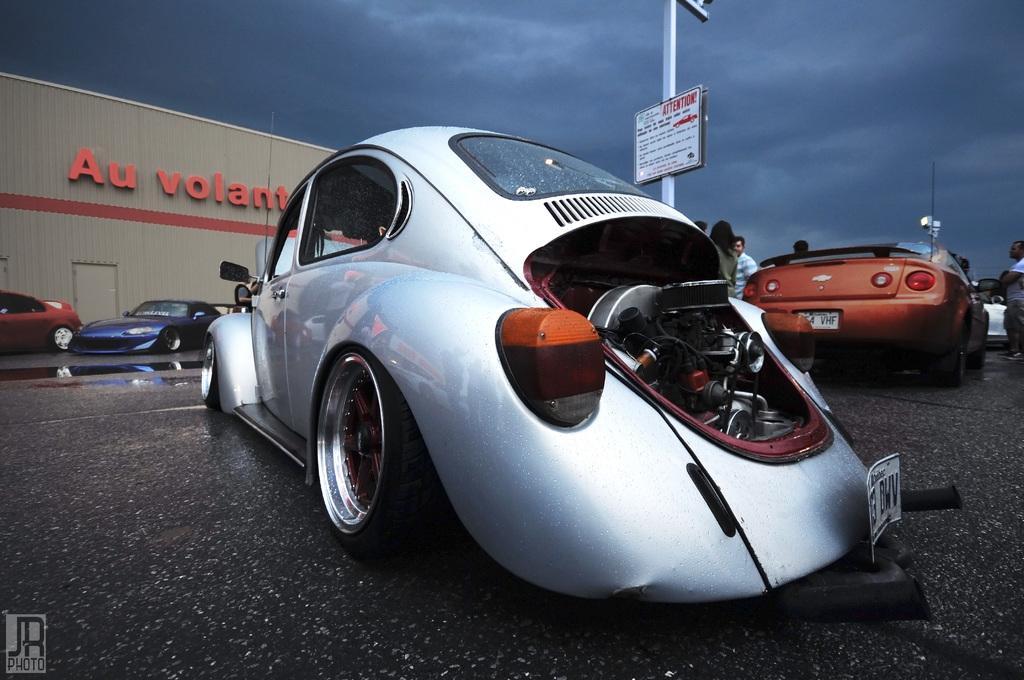Could you give a brief overview of what you see in this image? In this picture we can see cars and a group of people standing on the road and in the background we can see a board, pole, sky with clouds. 